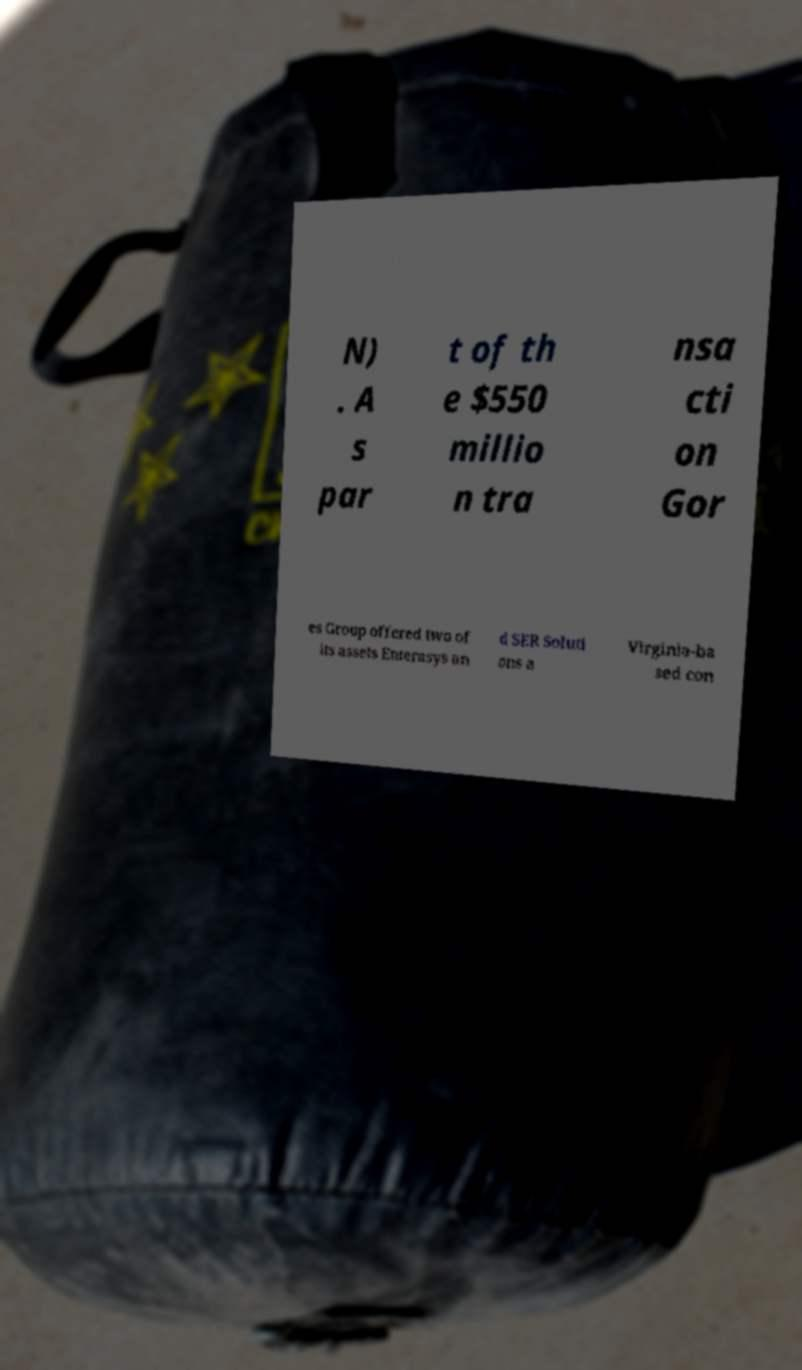Could you extract and type out the text from this image? N) . A s par t of th e $550 millio n tra nsa cti on Gor es Group offered two of its assets Enterasys an d SER Soluti ons a Virginia-ba sed con 